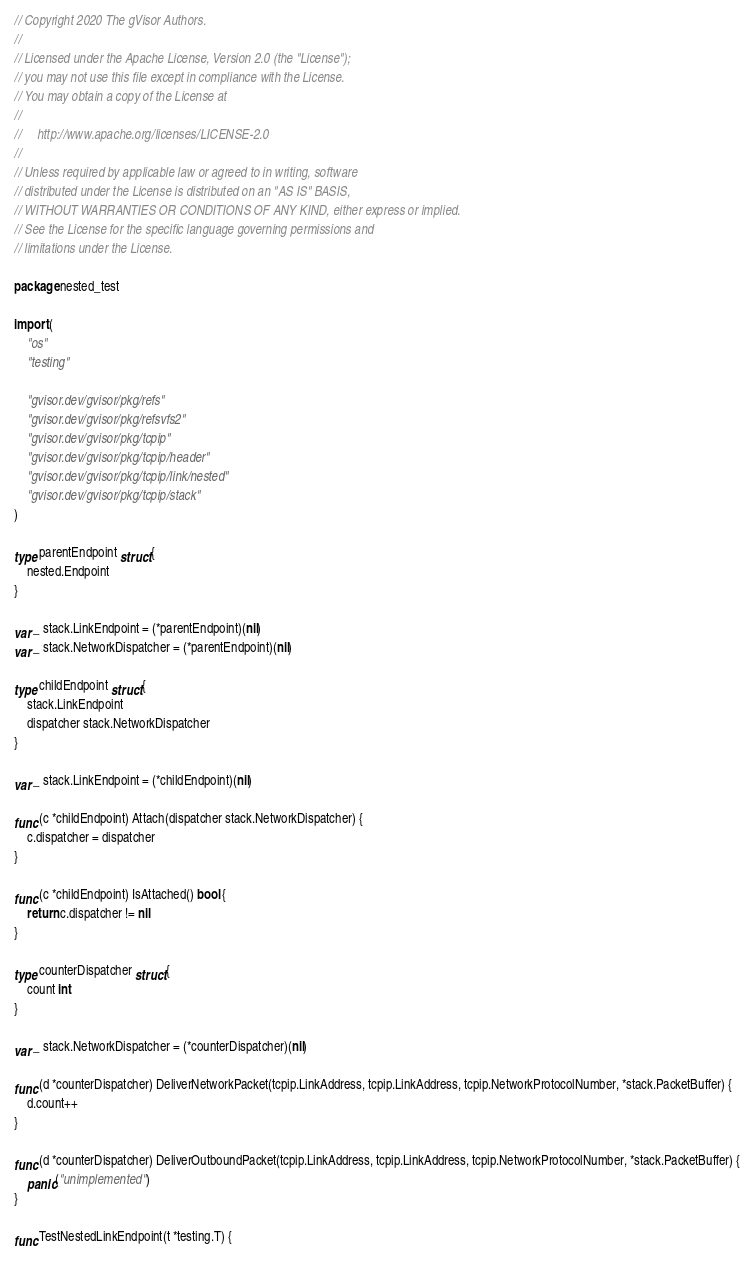<code> <loc_0><loc_0><loc_500><loc_500><_Go_>// Copyright 2020 The gVisor Authors.
//
// Licensed under the Apache License, Version 2.0 (the "License");
// you may not use this file except in compliance with the License.
// You may obtain a copy of the License at
//
//     http://www.apache.org/licenses/LICENSE-2.0
//
// Unless required by applicable law or agreed to in writing, software
// distributed under the License is distributed on an "AS IS" BASIS,
// WITHOUT WARRANTIES OR CONDITIONS OF ANY KIND, either express or implied.
// See the License for the specific language governing permissions and
// limitations under the License.

package nested_test

import (
	"os"
	"testing"

	"gvisor.dev/gvisor/pkg/refs"
	"gvisor.dev/gvisor/pkg/refsvfs2"
	"gvisor.dev/gvisor/pkg/tcpip"
	"gvisor.dev/gvisor/pkg/tcpip/header"
	"gvisor.dev/gvisor/pkg/tcpip/link/nested"
	"gvisor.dev/gvisor/pkg/tcpip/stack"
)

type parentEndpoint struct {
	nested.Endpoint
}

var _ stack.LinkEndpoint = (*parentEndpoint)(nil)
var _ stack.NetworkDispatcher = (*parentEndpoint)(nil)

type childEndpoint struct {
	stack.LinkEndpoint
	dispatcher stack.NetworkDispatcher
}

var _ stack.LinkEndpoint = (*childEndpoint)(nil)

func (c *childEndpoint) Attach(dispatcher stack.NetworkDispatcher) {
	c.dispatcher = dispatcher
}

func (c *childEndpoint) IsAttached() bool {
	return c.dispatcher != nil
}

type counterDispatcher struct {
	count int
}

var _ stack.NetworkDispatcher = (*counterDispatcher)(nil)

func (d *counterDispatcher) DeliverNetworkPacket(tcpip.LinkAddress, tcpip.LinkAddress, tcpip.NetworkProtocolNumber, *stack.PacketBuffer) {
	d.count++
}

func (d *counterDispatcher) DeliverOutboundPacket(tcpip.LinkAddress, tcpip.LinkAddress, tcpip.NetworkProtocolNumber, *stack.PacketBuffer) {
	panic("unimplemented")
}

func TestNestedLinkEndpoint(t *testing.T) {</code> 